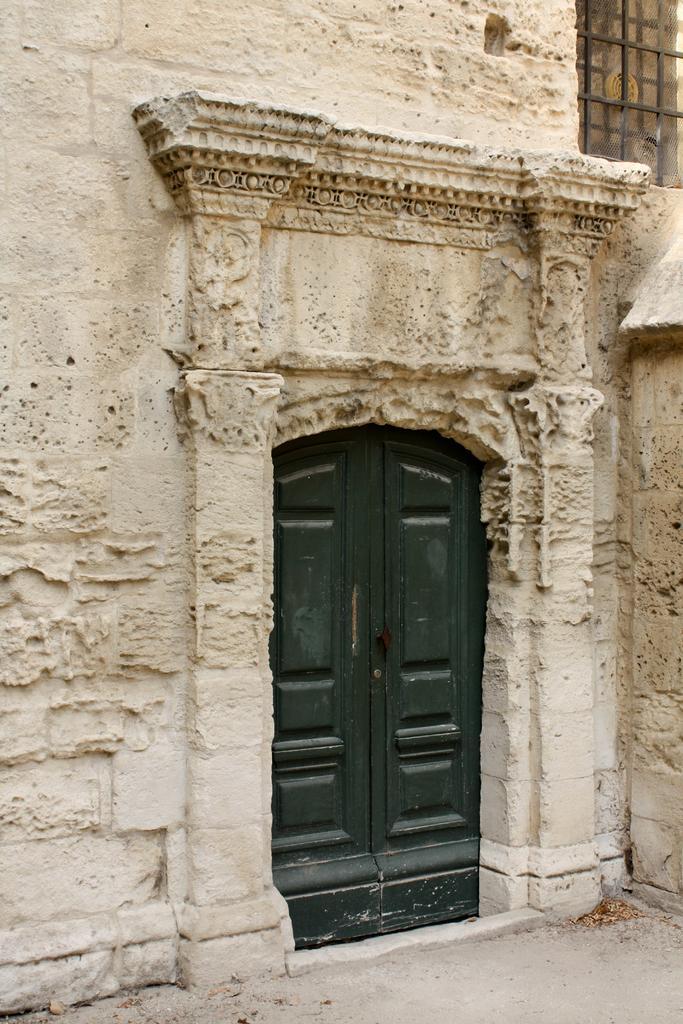Please provide a concise description of this image. In this picture we can see wall, door and window. 